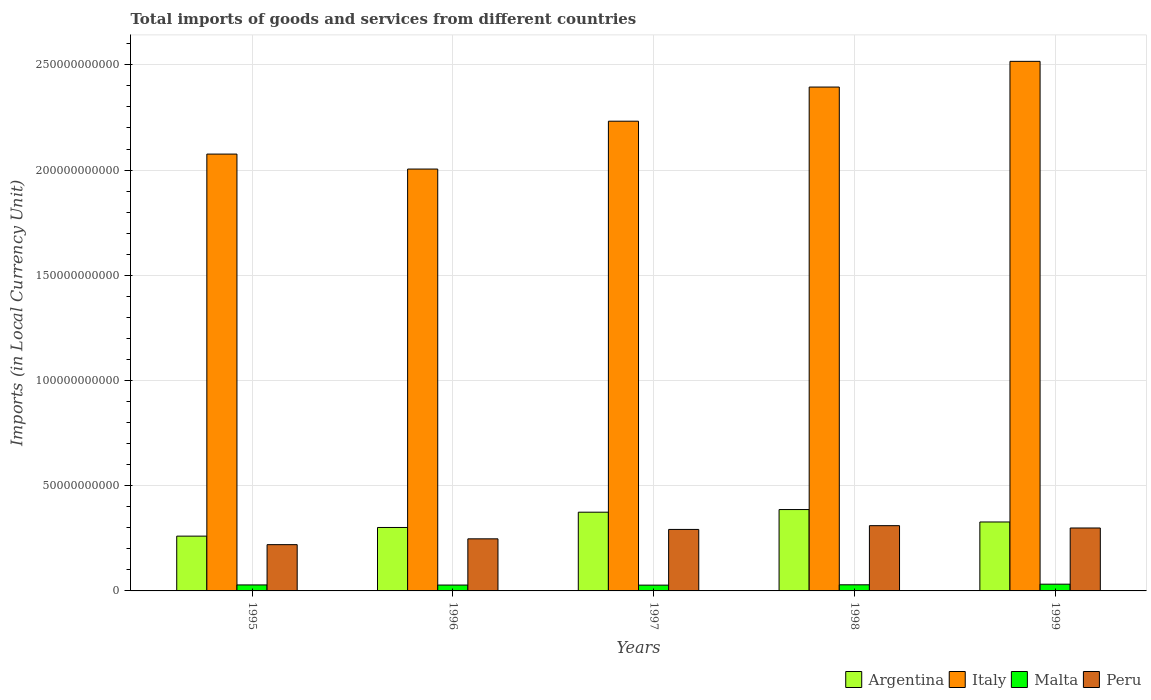How many groups of bars are there?
Provide a succinct answer. 5. Are the number of bars on each tick of the X-axis equal?
Offer a terse response. Yes. How many bars are there on the 4th tick from the left?
Offer a terse response. 4. How many bars are there on the 2nd tick from the right?
Provide a short and direct response. 4. What is the label of the 3rd group of bars from the left?
Your answer should be very brief. 1997. In how many cases, is the number of bars for a given year not equal to the number of legend labels?
Offer a very short reply. 0. What is the Amount of goods and services imports in Peru in 1998?
Provide a short and direct response. 3.10e+1. Across all years, what is the maximum Amount of goods and services imports in Argentina?
Provide a succinct answer. 3.87e+1. Across all years, what is the minimum Amount of goods and services imports in Peru?
Your answer should be compact. 2.20e+1. In which year was the Amount of goods and services imports in Italy maximum?
Give a very brief answer. 1999. What is the total Amount of goods and services imports in Argentina in the graph?
Provide a succinct answer. 1.65e+11. What is the difference between the Amount of goods and services imports in Malta in 1996 and that in 1998?
Provide a succinct answer. -1.18e+08. What is the difference between the Amount of goods and services imports in Italy in 1997 and the Amount of goods and services imports in Malta in 1999?
Make the answer very short. 2.20e+11. What is the average Amount of goods and services imports in Italy per year?
Provide a succinct answer. 2.24e+11. In the year 1995, what is the difference between the Amount of goods and services imports in Peru and Amount of goods and services imports in Malta?
Offer a very short reply. 1.91e+1. What is the ratio of the Amount of goods and services imports in Peru in 1995 to that in 1998?
Your answer should be very brief. 0.71. Is the Amount of goods and services imports in Peru in 1996 less than that in 1998?
Your answer should be very brief. Yes. Is the difference between the Amount of goods and services imports in Peru in 1997 and 1998 greater than the difference between the Amount of goods and services imports in Malta in 1997 and 1998?
Your answer should be very brief. No. What is the difference between the highest and the second highest Amount of goods and services imports in Peru?
Your response must be concise. 1.11e+09. What is the difference between the highest and the lowest Amount of goods and services imports in Argentina?
Your response must be concise. 1.26e+1. In how many years, is the Amount of goods and services imports in Peru greater than the average Amount of goods and services imports in Peru taken over all years?
Your answer should be compact. 3. Is it the case that in every year, the sum of the Amount of goods and services imports in Argentina and Amount of goods and services imports in Malta is greater than the sum of Amount of goods and services imports in Peru and Amount of goods and services imports in Italy?
Your answer should be compact. Yes. What does the 1st bar from the left in 1995 represents?
Your answer should be compact. Argentina. What does the 3rd bar from the right in 1995 represents?
Provide a short and direct response. Italy. Are all the bars in the graph horizontal?
Your answer should be compact. No. Does the graph contain grids?
Offer a very short reply. Yes. How are the legend labels stacked?
Provide a short and direct response. Horizontal. What is the title of the graph?
Offer a terse response. Total imports of goods and services from different countries. What is the label or title of the Y-axis?
Your answer should be compact. Imports (in Local Currency Unit). What is the Imports (in Local Currency Unit) of Argentina in 1995?
Give a very brief answer. 2.60e+1. What is the Imports (in Local Currency Unit) in Italy in 1995?
Your answer should be compact. 2.08e+11. What is the Imports (in Local Currency Unit) of Malta in 1995?
Your response must be concise. 2.85e+09. What is the Imports (in Local Currency Unit) in Peru in 1995?
Make the answer very short. 2.20e+1. What is the Imports (in Local Currency Unit) in Argentina in 1996?
Offer a terse response. 3.01e+1. What is the Imports (in Local Currency Unit) of Italy in 1996?
Provide a short and direct response. 2.00e+11. What is the Imports (in Local Currency Unit) in Malta in 1996?
Offer a very short reply. 2.79e+09. What is the Imports (in Local Currency Unit) of Peru in 1996?
Your response must be concise. 2.48e+1. What is the Imports (in Local Currency Unit) in Argentina in 1997?
Offer a very short reply. 3.74e+1. What is the Imports (in Local Currency Unit) of Italy in 1997?
Keep it short and to the point. 2.23e+11. What is the Imports (in Local Currency Unit) in Malta in 1997?
Keep it short and to the point. 2.75e+09. What is the Imports (in Local Currency Unit) in Peru in 1997?
Keep it short and to the point. 2.92e+1. What is the Imports (in Local Currency Unit) in Argentina in 1998?
Give a very brief answer. 3.87e+1. What is the Imports (in Local Currency Unit) of Italy in 1998?
Your response must be concise. 2.39e+11. What is the Imports (in Local Currency Unit) of Malta in 1998?
Give a very brief answer. 2.91e+09. What is the Imports (in Local Currency Unit) in Peru in 1998?
Make the answer very short. 3.10e+1. What is the Imports (in Local Currency Unit) of Argentina in 1999?
Your response must be concise. 3.28e+1. What is the Imports (in Local Currency Unit) of Italy in 1999?
Your answer should be compact. 2.52e+11. What is the Imports (in Local Currency Unit) in Malta in 1999?
Keep it short and to the point. 3.20e+09. What is the Imports (in Local Currency Unit) in Peru in 1999?
Offer a very short reply. 2.99e+1. Across all years, what is the maximum Imports (in Local Currency Unit) in Argentina?
Offer a terse response. 3.87e+1. Across all years, what is the maximum Imports (in Local Currency Unit) of Italy?
Provide a succinct answer. 2.52e+11. Across all years, what is the maximum Imports (in Local Currency Unit) of Malta?
Give a very brief answer. 3.20e+09. Across all years, what is the maximum Imports (in Local Currency Unit) of Peru?
Your answer should be very brief. 3.10e+1. Across all years, what is the minimum Imports (in Local Currency Unit) in Argentina?
Offer a terse response. 2.60e+1. Across all years, what is the minimum Imports (in Local Currency Unit) of Italy?
Provide a short and direct response. 2.00e+11. Across all years, what is the minimum Imports (in Local Currency Unit) of Malta?
Make the answer very short. 2.75e+09. Across all years, what is the minimum Imports (in Local Currency Unit) in Peru?
Your response must be concise. 2.20e+1. What is the total Imports (in Local Currency Unit) of Argentina in the graph?
Give a very brief answer. 1.65e+11. What is the total Imports (in Local Currency Unit) in Italy in the graph?
Offer a terse response. 1.12e+12. What is the total Imports (in Local Currency Unit) in Malta in the graph?
Make the answer very short. 1.45e+1. What is the total Imports (in Local Currency Unit) in Peru in the graph?
Give a very brief answer. 1.37e+11. What is the difference between the Imports (in Local Currency Unit) in Argentina in 1995 and that in 1996?
Offer a terse response. -4.11e+09. What is the difference between the Imports (in Local Currency Unit) in Italy in 1995 and that in 1996?
Ensure brevity in your answer.  7.11e+09. What is the difference between the Imports (in Local Currency Unit) in Malta in 1995 and that in 1996?
Ensure brevity in your answer.  6.04e+07. What is the difference between the Imports (in Local Currency Unit) of Peru in 1995 and that in 1996?
Provide a short and direct response. -2.76e+09. What is the difference between the Imports (in Local Currency Unit) of Argentina in 1995 and that in 1997?
Your response must be concise. -1.14e+1. What is the difference between the Imports (in Local Currency Unit) in Italy in 1995 and that in 1997?
Provide a short and direct response. -1.56e+1. What is the difference between the Imports (in Local Currency Unit) in Malta in 1995 and that in 1997?
Provide a succinct answer. 9.92e+07. What is the difference between the Imports (in Local Currency Unit) of Peru in 1995 and that in 1997?
Offer a terse response. -7.23e+09. What is the difference between the Imports (in Local Currency Unit) of Argentina in 1995 and that in 1998?
Provide a succinct answer. -1.26e+1. What is the difference between the Imports (in Local Currency Unit) in Italy in 1995 and that in 1998?
Your answer should be very brief. -3.19e+1. What is the difference between the Imports (in Local Currency Unit) in Malta in 1995 and that in 1998?
Make the answer very short. -5.78e+07. What is the difference between the Imports (in Local Currency Unit) in Peru in 1995 and that in 1998?
Keep it short and to the point. -9.02e+09. What is the difference between the Imports (in Local Currency Unit) of Argentina in 1995 and that in 1999?
Offer a very short reply. -6.72e+09. What is the difference between the Imports (in Local Currency Unit) in Italy in 1995 and that in 1999?
Keep it short and to the point. -4.41e+1. What is the difference between the Imports (in Local Currency Unit) of Malta in 1995 and that in 1999?
Provide a short and direct response. -3.52e+08. What is the difference between the Imports (in Local Currency Unit) of Peru in 1995 and that in 1999?
Provide a short and direct response. -7.92e+09. What is the difference between the Imports (in Local Currency Unit) of Argentina in 1996 and that in 1997?
Provide a succinct answer. -7.27e+09. What is the difference between the Imports (in Local Currency Unit) of Italy in 1996 and that in 1997?
Provide a succinct answer. -2.27e+1. What is the difference between the Imports (in Local Currency Unit) of Malta in 1996 and that in 1997?
Your response must be concise. 3.88e+07. What is the difference between the Imports (in Local Currency Unit) in Peru in 1996 and that in 1997?
Offer a terse response. -4.47e+09. What is the difference between the Imports (in Local Currency Unit) in Argentina in 1996 and that in 1998?
Provide a short and direct response. -8.52e+09. What is the difference between the Imports (in Local Currency Unit) of Italy in 1996 and that in 1998?
Offer a very short reply. -3.90e+1. What is the difference between the Imports (in Local Currency Unit) of Malta in 1996 and that in 1998?
Keep it short and to the point. -1.18e+08. What is the difference between the Imports (in Local Currency Unit) in Peru in 1996 and that in 1998?
Offer a very short reply. -6.26e+09. What is the difference between the Imports (in Local Currency Unit) in Argentina in 1996 and that in 1999?
Your response must be concise. -2.61e+09. What is the difference between the Imports (in Local Currency Unit) of Italy in 1996 and that in 1999?
Ensure brevity in your answer.  -5.12e+1. What is the difference between the Imports (in Local Currency Unit) in Malta in 1996 and that in 1999?
Offer a terse response. -4.13e+08. What is the difference between the Imports (in Local Currency Unit) in Peru in 1996 and that in 1999?
Your answer should be very brief. -5.15e+09. What is the difference between the Imports (in Local Currency Unit) of Argentina in 1997 and that in 1998?
Make the answer very short. -1.25e+09. What is the difference between the Imports (in Local Currency Unit) of Italy in 1997 and that in 1998?
Provide a short and direct response. -1.62e+1. What is the difference between the Imports (in Local Currency Unit) in Malta in 1997 and that in 1998?
Offer a terse response. -1.57e+08. What is the difference between the Imports (in Local Currency Unit) of Peru in 1997 and that in 1998?
Provide a short and direct response. -1.79e+09. What is the difference between the Imports (in Local Currency Unit) of Argentina in 1997 and that in 1999?
Your response must be concise. 4.65e+09. What is the difference between the Imports (in Local Currency Unit) of Italy in 1997 and that in 1999?
Your response must be concise. -2.84e+1. What is the difference between the Imports (in Local Currency Unit) in Malta in 1997 and that in 1999?
Offer a very short reply. -4.52e+08. What is the difference between the Imports (in Local Currency Unit) in Peru in 1997 and that in 1999?
Offer a terse response. -6.88e+08. What is the difference between the Imports (in Local Currency Unit) in Argentina in 1998 and that in 1999?
Provide a short and direct response. 5.90e+09. What is the difference between the Imports (in Local Currency Unit) in Italy in 1998 and that in 1999?
Provide a short and direct response. -1.22e+1. What is the difference between the Imports (in Local Currency Unit) in Malta in 1998 and that in 1999?
Keep it short and to the point. -2.94e+08. What is the difference between the Imports (in Local Currency Unit) of Peru in 1998 and that in 1999?
Give a very brief answer. 1.11e+09. What is the difference between the Imports (in Local Currency Unit) in Argentina in 1995 and the Imports (in Local Currency Unit) in Italy in 1996?
Keep it short and to the point. -1.74e+11. What is the difference between the Imports (in Local Currency Unit) in Argentina in 1995 and the Imports (in Local Currency Unit) in Malta in 1996?
Keep it short and to the point. 2.32e+1. What is the difference between the Imports (in Local Currency Unit) in Argentina in 1995 and the Imports (in Local Currency Unit) in Peru in 1996?
Your answer should be very brief. 1.28e+09. What is the difference between the Imports (in Local Currency Unit) of Italy in 1995 and the Imports (in Local Currency Unit) of Malta in 1996?
Provide a short and direct response. 2.05e+11. What is the difference between the Imports (in Local Currency Unit) in Italy in 1995 and the Imports (in Local Currency Unit) in Peru in 1996?
Keep it short and to the point. 1.83e+11. What is the difference between the Imports (in Local Currency Unit) of Malta in 1995 and the Imports (in Local Currency Unit) of Peru in 1996?
Your answer should be very brief. -2.19e+1. What is the difference between the Imports (in Local Currency Unit) in Argentina in 1995 and the Imports (in Local Currency Unit) in Italy in 1997?
Give a very brief answer. -1.97e+11. What is the difference between the Imports (in Local Currency Unit) of Argentina in 1995 and the Imports (in Local Currency Unit) of Malta in 1997?
Your answer should be very brief. 2.33e+1. What is the difference between the Imports (in Local Currency Unit) of Argentina in 1995 and the Imports (in Local Currency Unit) of Peru in 1997?
Keep it short and to the point. -3.18e+09. What is the difference between the Imports (in Local Currency Unit) in Italy in 1995 and the Imports (in Local Currency Unit) in Malta in 1997?
Your answer should be very brief. 2.05e+11. What is the difference between the Imports (in Local Currency Unit) in Italy in 1995 and the Imports (in Local Currency Unit) in Peru in 1997?
Keep it short and to the point. 1.78e+11. What is the difference between the Imports (in Local Currency Unit) of Malta in 1995 and the Imports (in Local Currency Unit) of Peru in 1997?
Provide a short and direct response. -2.64e+1. What is the difference between the Imports (in Local Currency Unit) in Argentina in 1995 and the Imports (in Local Currency Unit) in Italy in 1998?
Ensure brevity in your answer.  -2.13e+11. What is the difference between the Imports (in Local Currency Unit) in Argentina in 1995 and the Imports (in Local Currency Unit) in Malta in 1998?
Give a very brief answer. 2.31e+1. What is the difference between the Imports (in Local Currency Unit) of Argentina in 1995 and the Imports (in Local Currency Unit) of Peru in 1998?
Provide a succinct answer. -4.98e+09. What is the difference between the Imports (in Local Currency Unit) of Italy in 1995 and the Imports (in Local Currency Unit) of Malta in 1998?
Your answer should be very brief. 2.05e+11. What is the difference between the Imports (in Local Currency Unit) of Italy in 1995 and the Imports (in Local Currency Unit) of Peru in 1998?
Your answer should be compact. 1.77e+11. What is the difference between the Imports (in Local Currency Unit) in Malta in 1995 and the Imports (in Local Currency Unit) in Peru in 1998?
Keep it short and to the point. -2.82e+1. What is the difference between the Imports (in Local Currency Unit) in Argentina in 1995 and the Imports (in Local Currency Unit) in Italy in 1999?
Make the answer very short. -2.26e+11. What is the difference between the Imports (in Local Currency Unit) of Argentina in 1995 and the Imports (in Local Currency Unit) of Malta in 1999?
Your answer should be very brief. 2.28e+1. What is the difference between the Imports (in Local Currency Unit) in Argentina in 1995 and the Imports (in Local Currency Unit) in Peru in 1999?
Keep it short and to the point. -3.87e+09. What is the difference between the Imports (in Local Currency Unit) of Italy in 1995 and the Imports (in Local Currency Unit) of Malta in 1999?
Provide a succinct answer. 2.04e+11. What is the difference between the Imports (in Local Currency Unit) of Italy in 1995 and the Imports (in Local Currency Unit) of Peru in 1999?
Offer a very short reply. 1.78e+11. What is the difference between the Imports (in Local Currency Unit) of Malta in 1995 and the Imports (in Local Currency Unit) of Peru in 1999?
Provide a short and direct response. -2.71e+1. What is the difference between the Imports (in Local Currency Unit) of Argentina in 1996 and the Imports (in Local Currency Unit) of Italy in 1997?
Give a very brief answer. -1.93e+11. What is the difference between the Imports (in Local Currency Unit) in Argentina in 1996 and the Imports (in Local Currency Unit) in Malta in 1997?
Give a very brief answer. 2.74e+1. What is the difference between the Imports (in Local Currency Unit) of Argentina in 1996 and the Imports (in Local Currency Unit) of Peru in 1997?
Offer a very short reply. 9.29e+08. What is the difference between the Imports (in Local Currency Unit) of Italy in 1996 and the Imports (in Local Currency Unit) of Malta in 1997?
Offer a very short reply. 1.98e+11. What is the difference between the Imports (in Local Currency Unit) of Italy in 1996 and the Imports (in Local Currency Unit) of Peru in 1997?
Your answer should be very brief. 1.71e+11. What is the difference between the Imports (in Local Currency Unit) in Malta in 1996 and the Imports (in Local Currency Unit) in Peru in 1997?
Offer a terse response. -2.64e+1. What is the difference between the Imports (in Local Currency Unit) of Argentina in 1996 and the Imports (in Local Currency Unit) of Italy in 1998?
Ensure brevity in your answer.  -2.09e+11. What is the difference between the Imports (in Local Currency Unit) of Argentina in 1996 and the Imports (in Local Currency Unit) of Malta in 1998?
Provide a succinct answer. 2.72e+1. What is the difference between the Imports (in Local Currency Unit) of Argentina in 1996 and the Imports (in Local Currency Unit) of Peru in 1998?
Give a very brief answer. -8.65e+08. What is the difference between the Imports (in Local Currency Unit) in Italy in 1996 and the Imports (in Local Currency Unit) in Malta in 1998?
Keep it short and to the point. 1.98e+11. What is the difference between the Imports (in Local Currency Unit) of Italy in 1996 and the Imports (in Local Currency Unit) of Peru in 1998?
Keep it short and to the point. 1.69e+11. What is the difference between the Imports (in Local Currency Unit) of Malta in 1996 and the Imports (in Local Currency Unit) of Peru in 1998?
Make the answer very short. -2.82e+1. What is the difference between the Imports (in Local Currency Unit) of Argentina in 1996 and the Imports (in Local Currency Unit) of Italy in 1999?
Make the answer very short. -2.22e+11. What is the difference between the Imports (in Local Currency Unit) in Argentina in 1996 and the Imports (in Local Currency Unit) in Malta in 1999?
Give a very brief answer. 2.69e+1. What is the difference between the Imports (in Local Currency Unit) in Argentina in 1996 and the Imports (in Local Currency Unit) in Peru in 1999?
Your response must be concise. 2.41e+08. What is the difference between the Imports (in Local Currency Unit) of Italy in 1996 and the Imports (in Local Currency Unit) of Malta in 1999?
Provide a succinct answer. 1.97e+11. What is the difference between the Imports (in Local Currency Unit) in Italy in 1996 and the Imports (in Local Currency Unit) in Peru in 1999?
Your answer should be compact. 1.71e+11. What is the difference between the Imports (in Local Currency Unit) in Malta in 1996 and the Imports (in Local Currency Unit) in Peru in 1999?
Offer a very short reply. -2.71e+1. What is the difference between the Imports (in Local Currency Unit) of Argentina in 1997 and the Imports (in Local Currency Unit) of Italy in 1998?
Offer a terse response. -2.02e+11. What is the difference between the Imports (in Local Currency Unit) of Argentina in 1997 and the Imports (in Local Currency Unit) of Malta in 1998?
Provide a short and direct response. 3.45e+1. What is the difference between the Imports (in Local Currency Unit) of Argentina in 1997 and the Imports (in Local Currency Unit) of Peru in 1998?
Give a very brief answer. 6.40e+09. What is the difference between the Imports (in Local Currency Unit) in Italy in 1997 and the Imports (in Local Currency Unit) in Malta in 1998?
Give a very brief answer. 2.20e+11. What is the difference between the Imports (in Local Currency Unit) of Italy in 1997 and the Imports (in Local Currency Unit) of Peru in 1998?
Make the answer very short. 1.92e+11. What is the difference between the Imports (in Local Currency Unit) in Malta in 1997 and the Imports (in Local Currency Unit) in Peru in 1998?
Ensure brevity in your answer.  -2.83e+1. What is the difference between the Imports (in Local Currency Unit) of Argentina in 1997 and the Imports (in Local Currency Unit) of Italy in 1999?
Offer a terse response. -2.14e+11. What is the difference between the Imports (in Local Currency Unit) of Argentina in 1997 and the Imports (in Local Currency Unit) of Malta in 1999?
Offer a very short reply. 3.42e+1. What is the difference between the Imports (in Local Currency Unit) of Argentina in 1997 and the Imports (in Local Currency Unit) of Peru in 1999?
Make the answer very short. 7.51e+09. What is the difference between the Imports (in Local Currency Unit) of Italy in 1997 and the Imports (in Local Currency Unit) of Malta in 1999?
Your answer should be compact. 2.20e+11. What is the difference between the Imports (in Local Currency Unit) of Italy in 1997 and the Imports (in Local Currency Unit) of Peru in 1999?
Give a very brief answer. 1.93e+11. What is the difference between the Imports (in Local Currency Unit) in Malta in 1997 and the Imports (in Local Currency Unit) in Peru in 1999?
Offer a very short reply. -2.72e+1. What is the difference between the Imports (in Local Currency Unit) in Argentina in 1998 and the Imports (in Local Currency Unit) in Italy in 1999?
Your answer should be very brief. -2.13e+11. What is the difference between the Imports (in Local Currency Unit) in Argentina in 1998 and the Imports (in Local Currency Unit) in Malta in 1999?
Your answer should be very brief. 3.55e+1. What is the difference between the Imports (in Local Currency Unit) of Argentina in 1998 and the Imports (in Local Currency Unit) of Peru in 1999?
Your answer should be very brief. 8.76e+09. What is the difference between the Imports (in Local Currency Unit) of Italy in 1998 and the Imports (in Local Currency Unit) of Malta in 1999?
Your answer should be very brief. 2.36e+11. What is the difference between the Imports (in Local Currency Unit) in Italy in 1998 and the Imports (in Local Currency Unit) in Peru in 1999?
Give a very brief answer. 2.10e+11. What is the difference between the Imports (in Local Currency Unit) in Malta in 1998 and the Imports (in Local Currency Unit) in Peru in 1999?
Your answer should be compact. -2.70e+1. What is the average Imports (in Local Currency Unit) of Argentina per year?
Give a very brief answer. 3.30e+1. What is the average Imports (in Local Currency Unit) of Italy per year?
Your answer should be compact. 2.24e+11. What is the average Imports (in Local Currency Unit) of Malta per year?
Offer a very short reply. 2.90e+09. What is the average Imports (in Local Currency Unit) of Peru per year?
Make the answer very short. 2.74e+1. In the year 1995, what is the difference between the Imports (in Local Currency Unit) in Argentina and Imports (in Local Currency Unit) in Italy?
Your answer should be compact. -1.82e+11. In the year 1995, what is the difference between the Imports (in Local Currency Unit) in Argentina and Imports (in Local Currency Unit) in Malta?
Ensure brevity in your answer.  2.32e+1. In the year 1995, what is the difference between the Imports (in Local Currency Unit) of Argentina and Imports (in Local Currency Unit) of Peru?
Your answer should be compact. 4.05e+09. In the year 1995, what is the difference between the Imports (in Local Currency Unit) in Italy and Imports (in Local Currency Unit) in Malta?
Provide a succinct answer. 2.05e+11. In the year 1995, what is the difference between the Imports (in Local Currency Unit) in Italy and Imports (in Local Currency Unit) in Peru?
Provide a short and direct response. 1.86e+11. In the year 1995, what is the difference between the Imports (in Local Currency Unit) in Malta and Imports (in Local Currency Unit) in Peru?
Keep it short and to the point. -1.91e+1. In the year 1996, what is the difference between the Imports (in Local Currency Unit) in Argentina and Imports (in Local Currency Unit) in Italy?
Make the answer very short. -1.70e+11. In the year 1996, what is the difference between the Imports (in Local Currency Unit) of Argentina and Imports (in Local Currency Unit) of Malta?
Ensure brevity in your answer.  2.74e+1. In the year 1996, what is the difference between the Imports (in Local Currency Unit) of Argentina and Imports (in Local Currency Unit) of Peru?
Give a very brief answer. 5.39e+09. In the year 1996, what is the difference between the Imports (in Local Currency Unit) in Italy and Imports (in Local Currency Unit) in Malta?
Ensure brevity in your answer.  1.98e+11. In the year 1996, what is the difference between the Imports (in Local Currency Unit) of Italy and Imports (in Local Currency Unit) of Peru?
Offer a very short reply. 1.76e+11. In the year 1996, what is the difference between the Imports (in Local Currency Unit) of Malta and Imports (in Local Currency Unit) of Peru?
Make the answer very short. -2.20e+1. In the year 1997, what is the difference between the Imports (in Local Currency Unit) of Argentina and Imports (in Local Currency Unit) of Italy?
Your answer should be very brief. -1.86e+11. In the year 1997, what is the difference between the Imports (in Local Currency Unit) of Argentina and Imports (in Local Currency Unit) of Malta?
Give a very brief answer. 3.47e+1. In the year 1997, what is the difference between the Imports (in Local Currency Unit) of Argentina and Imports (in Local Currency Unit) of Peru?
Make the answer very short. 8.19e+09. In the year 1997, what is the difference between the Imports (in Local Currency Unit) in Italy and Imports (in Local Currency Unit) in Malta?
Give a very brief answer. 2.20e+11. In the year 1997, what is the difference between the Imports (in Local Currency Unit) in Italy and Imports (in Local Currency Unit) in Peru?
Offer a terse response. 1.94e+11. In the year 1997, what is the difference between the Imports (in Local Currency Unit) of Malta and Imports (in Local Currency Unit) of Peru?
Ensure brevity in your answer.  -2.65e+1. In the year 1998, what is the difference between the Imports (in Local Currency Unit) in Argentina and Imports (in Local Currency Unit) in Italy?
Make the answer very short. -2.01e+11. In the year 1998, what is the difference between the Imports (in Local Currency Unit) of Argentina and Imports (in Local Currency Unit) of Malta?
Your answer should be compact. 3.58e+1. In the year 1998, what is the difference between the Imports (in Local Currency Unit) of Argentina and Imports (in Local Currency Unit) of Peru?
Offer a very short reply. 7.65e+09. In the year 1998, what is the difference between the Imports (in Local Currency Unit) of Italy and Imports (in Local Currency Unit) of Malta?
Your answer should be compact. 2.37e+11. In the year 1998, what is the difference between the Imports (in Local Currency Unit) in Italy and Imports (in Local Currency Unit) in Peru?
Provide a succinct answer. 2.08e+11. In the year 1998, what is the difference between the Imports (in Local Currency Unit) in Malta and Imports (in Local Currency Unit) in Peru?
Give a very brief answer. -2.81e+1. In the year 1999, what is the difference between the Imports (in Local Currency Unit) of Argentina and Imports (in Local Currency Unit) of Italy?
Your answer should be compact. -2.19e+11. In the year 1999, what is the difference between the Imports (in Local Currency Unit) of Argentina and Imports (in Local Currency Unit) of Malta?
Make the answer very short. 2.96e+1. In the year 1999, what is the difference between the Imports (in Local Currency Unit) of Argentina and Imports (in Local Currency Unit) of Peru?
Your answer should be compact. 2.86e+09. In the year 1999, what is the difference between the Imports (in Local Currency Unit) in Italy and Imports (in Local Currency Unit) in Malta?
Your answer should be very brief. 2.48e+11. In the year 1999, what is the difference between the Imports (in Local Currency Unit) in Italy and Imports (in Local Currency Unit) in Peru?
Your response must be concise. 2.22e+11. In the year 1999, what is the difference between the Imports (in Local Currency Unit) of Malta and Imports (in Local Currency Unit) of Peru?
Your response must be concise. -2.67e+1. What is the ratio of the Imports (in Local Currency Unit) of Argentina in 1995 to that in 1996?
Provide a succinct answer. 0.86. What is the ratio of the Imports (in Local Currency Unit) of Italy in 1995 to that in 1996?
Provide a short and direct response. 1.04. What is the ratio of the Imports (in Local Currency Unit) of Malta in 1995 to that in 1996?
Give a very brief answer. 1.02. What is the ratio of the Imports (in Local Currency Unit) in Peru in 1995 to that in 1996?
Make the answer very short. 0.89. What is the ratio of the Imports (in Local Currency Unit) of Argentina in 1995 to that in 1997?
Provide a short and direct response. 0.7. What is the ratio of the Imports (in Local Currency Unit) of Malta in 1995 to that in 1997?
Your answer should be very brief. 1.04. What is the ratio of the Imports (in Local Currency Unit) of Peru in 1995 to that in 1997?
Provide a succinct answer. 0.75. What is the ratio of the Imports (in Local Currency Unit) in Argentina in 1995 to that in 1998?
Provide a short and direct response. 0.67. What is the ratio of the Imports (in Local Currency Unit) in Italy in 1995 to that in 1998?
Keep it short and to the point. 0.87. What is the ratio of the Imports (in Local Currency Unit) in Malta in 1995 to that in 1998?
Provide a succinct answer. 0.98. What is the ratio of the Imports (in Local Currency Unit) in Peru in 1995 to that in 1998?
Give a very brief answer. 0.71. What is the ratio of the Imports (in Local Currency Unit) of Argentina in 1995 to that in 1999?
Your answer should be very brief. 0.79. What is the ratio of the Imports (in Local Currency Unit) in Italy in 1995 to that in 1999?
Offer a very short reply. 0.82. What is the ratio of the Imports (in Local Currency Unit) in Malta in 1995 to that in 1999?
Keep it short and to the point. 0.89. What is the ratio of the Imports (in Local Currency Unit) in Peru in 1995 to that in 1999?
Provide a short and direct response. 0.74. What is the ratio of the Imports (in Local Currency Unit) of Argentina in 1996 to that in 1997?
Ensure brevity in your answer.  0.81. What is the ratio of the Imports (in Local Currency Unit) in Italy in 1996 to that in 1997?
Offer a very short reply. 0.9. What is the ratio of the Imports (in Local Currency Unit) of Malta in 1996 to that in 1997?
Your answer should be compact. 1.01. What is the ratio of the Imports (in Local Currency Unit) in Peru in 1996 to that in 1997?
Ensure brevity in your answer.  0.85. What is the ratio of the Imports (in Local Currency Unit) in Argentina in 1996 to that in 1998?
Your answer should be very brief. 0.78. What is the ratio of the Imports (in Local Currency Unit) of Italy in 1996 to that in 1998?
Provide a succinct answer. 0.84. What is the ratio of the Imports (in Local Currency Unit) in Malta in 1996 to that in 1998?
Make the answer very short. 0.96. What is the ratio of the Imports (in Local Currency Unit) of Peru in 1996 to that in 1998?
Offer a terse response. 0.8. What is the ratio of the Imports (in Local Currency Unit) in Argentina in 1996 to that in 1999?
Offer a terse response. 0.92. What is the ratio of the Imports (in Local Currency Unit) in Italy in 1996 to that in 1999?
Ensure brevity in your answer.  0.8. What is the ratio of the Imports (in Local Currency Unit) in Malta in 1996 to that in 1999?
Provide a short and direct response. 0.87. What is the ratio of the Imports (in Local Currency Unit) in Peru in 1996 to that in 1999?
Give a very brief answer. 0.83. What is the ratio of the Imports (in Local Currency Unit) in Argentina in 1997 to that in 1998?
Your answer should be very brief. 0.97. What is the ratio of the Imports (in Local Currency Unit) in Italy in 1997 to that in 1998?
Your response must be concise. 0.93. What is the ratio of the Imports (in Local Currency Unit) of Malta in 1997 to that in 1998?
Give a very brief answer. 0.95. What is the ratio of the Imports (in Local Currency Unit) in Peru in 1997 to that in 1998?
Ensure brevity in your answer.  0.94. What is the ratio of the Imports (in Local Currency Unit) of Argentina in 1997 to that in 1999?
Give a very brief answer. 1.14. What is the ratio of the Imports (in Local Currency Unit) in Italy in 1997 to that in 1999?
Provide a succinct answer. 0.89. What is the ratio of the Imports (in Local Currency Unit) in Malta in 1997 to that in 1999?
Ensure brevity in your answer.  0.86. What is the ratio of the Imports (in Local Currency Unit) of Argentina in 1998 to that in 1999?
Ensure brevity in your answer.  1.18. What is the ratio of the Imports (in Local Currency Unit) of Italy in 1998 to that in 1999?
Offer a terse response. 0.95. What is the ratio of the Imports (in Local Currency Unit) of Malta in 1998 to that in 1999?
Provide a succinct answer. 0.91. What is the ratio of the Imports (in Local Currency Unit) in Peru in 1998 to that in 1999?
Ensure brevity in your answer.  1.04. What is the difference between the highest and the second highest Imports (in Local Currency Unit) in Argentina?
Your answer should be very brief. 1.25e+09. What is the difference between the highest and the second highest Imports (in Local Currency Unit) of Italy?
Your answer should be very brief. 1.22e+1. What is the difference between the highest and the second highest Imports (in Local Currency Unit) in Malta?
Keep it short and to the point. 2.94e+08. What is the difference between the highest and the second highest Imports (in Local Currency Unit) in Peru?
Provide a short and direct response. 1.11e+09. What is the difference between the highest and the lowest Imports (in Local Currency Unit) of Argentina?
Offer a very short reply. 1.26e+1. What is the difference between the highest and the lowest Imports (in Local Currency Unit) in Italy?
Ensure brevity in your answer.  5.12e+1. What is the difference between the highest and the lowest Imports (in Local Currency Unit) of Malta?
Ensure brevity in your answer.  4.52e+08. What is the difference between the highest and the lowest Imports (in Local Currency Unit) of Peru?
Ensure brevity in your answer.  9.02e+09. 